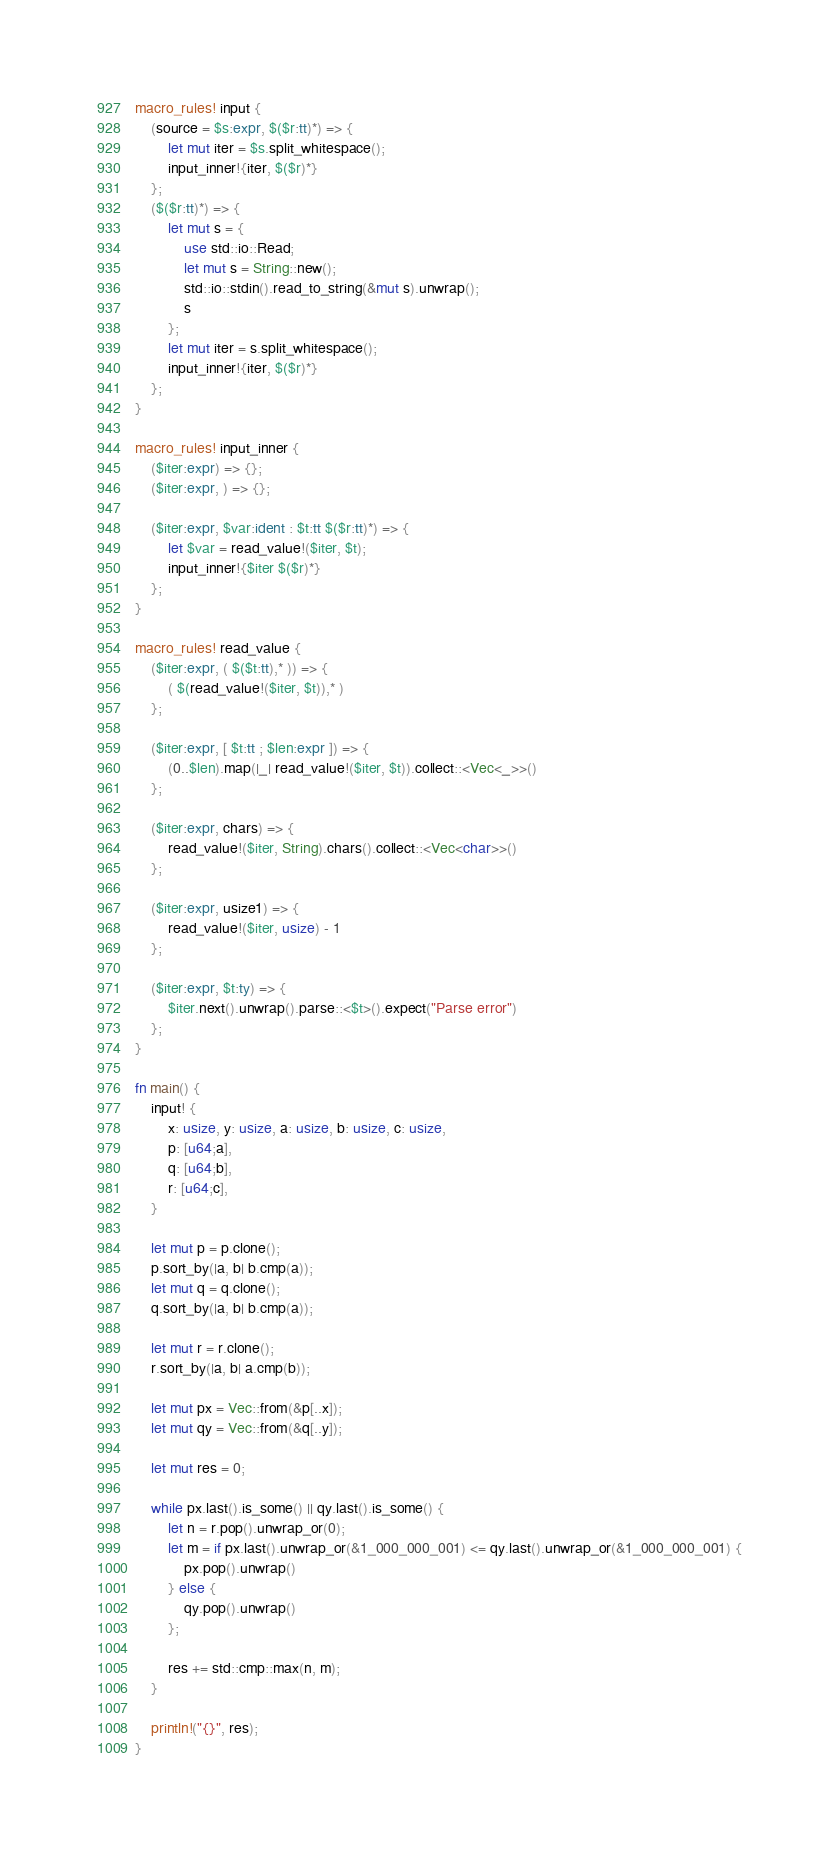Convert code to text. <code><loc_0><loc_0><loc_500><loc_500><_Rust_>macro_rules! input {
    (source = $s:expr, $($r:tt)*) => {
        let mut iter = $s.split_whitespace();
        input_inner!{iter, $($r)*}
    };
    ($($r:tt)*) => {
        let mut s = {
            use std::io::Read;
            let mut s = String::new();
            std::io::stdin().read_to_string(&mut s).unwrap();
            s
        };
        let mut iter = s.split_whitespace();
        input_inner!{iter, $($r)*}
    };
}

macro_rules! input_inner {
    ($iter:expr) => {};
    ($iter:expr, ) => {};

    ($iter:expr, $var:ident : $t:tt $($r:tt)*) => {
        let $var = read_value!($iter, $t);
        input_inner!{$iter $($r)*}
    };
}

macro_rules! read_value {
    ($iter:expr, ( $($t:tt),* )) => {
        ( $(read_value!($iter, $t)),* )
    };

    ($iter:expr, [ $t:tt ; $len:expr ]) => {
        (0..$len).map(|_| read_value!($iter, $t)).collect::<Vec<_>>()
    };

    ($iter:expr, chars) => {
        read_value!($iter, String).chars().collect::<Vec<char>>()
    };

    ($iter:expr, usize1) => {
        read_value!($iter, usize) - 1
    };

    ($iter:expr, $t:ty) => {
        $iter.next().unwrap().parse::<$t>().expect("Parse error")
    };
}

fn main() {
    input! {
        x: usize, y: usize, a: usize, b: usize, c: usize,
        p: [u64;a],
        q: [u64;b],
        r: [u64;c],
    }

    let mut p = p.clone();
    p.sort_by(|a, b| b.cmp(a));
    let mut q = q.clone();
    q.sort_by(|a, b| b.cmp(a));

    let mut r = r.clone();
    r.sort_by(|a, b| a.cmp(b));

    let mut px = Vec::from(&p[..x]);
    let mut qy = Vec::from(&q[..y]);

    let mut res = 0;

    while px.last().is_some() || qy.last().is_some() {
        let n = r.pop().unwrap_or(0);
        let m = if px.last().unwrap_or(&1_000_000_001) <= qy.last().unwrap_or(&1_000_000_001) {
            px.pop().unwrap()
        } else {
            qy.pop().unwrap()
        };

        res += std::cmp::max(n, m);
    }

    println!("{}", res);
}
</code> 